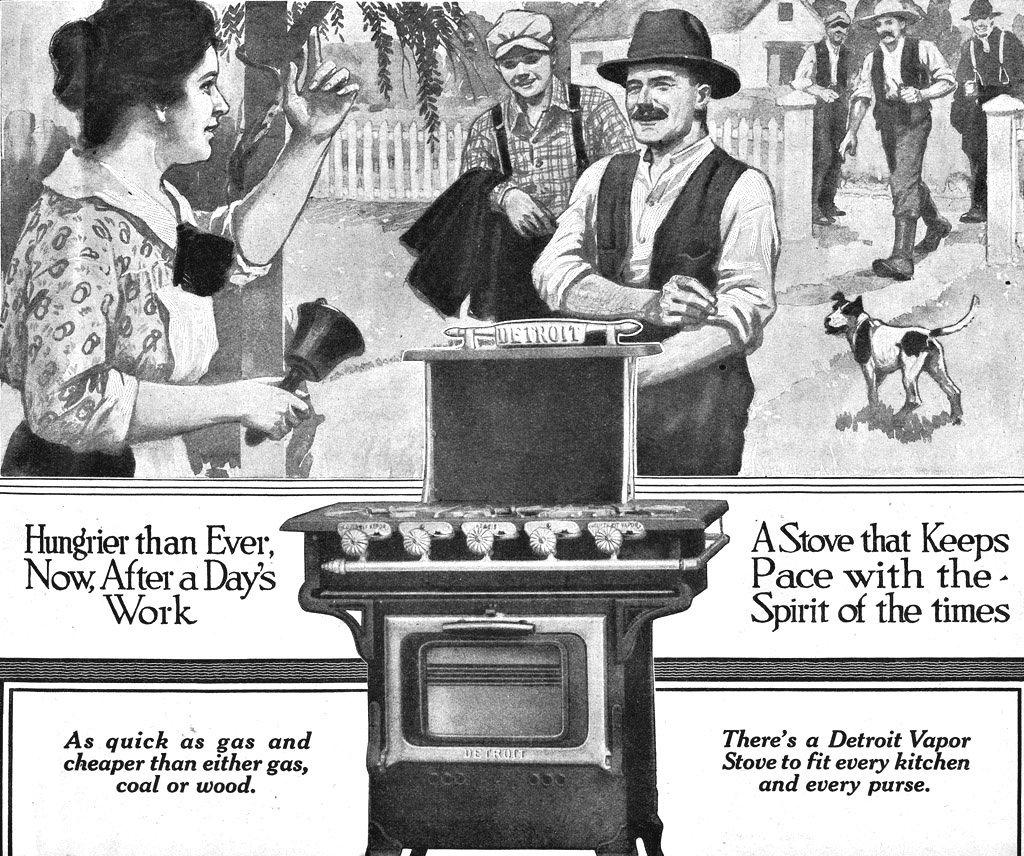What does a stove keep?
Ensure brevity in your answer.  Pace with the spirit of the times. What is the name of the stove?
Offer a terse response. Detroit. 